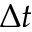Convert formula to latex. <formula><loc_0><loc_0><loc_500><loc_500>\Delta t</formula> 